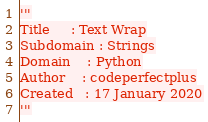<code> <loc_0><loc_0><loc_500><loc_500><_Python_>'''
Title     : Text Wrap
Subdomain : Strings
Domain    : Python
Author    : codeperfectplus
Created   : 17 January 2020
'''
</code> 